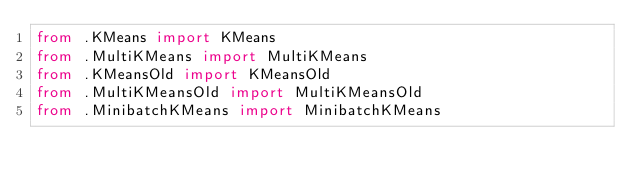<code> <loc_0><loc_0><loc_500><loc_500><_Python_>from .KMeans import KMeans
from .MultiKMeans import MultiKMeans
from .KMeansOld import KMeansOld
from .MultiKMeansOld import MultiKMeansOld
from .MinibatchKMeans import MinibatchKMeans</code> 